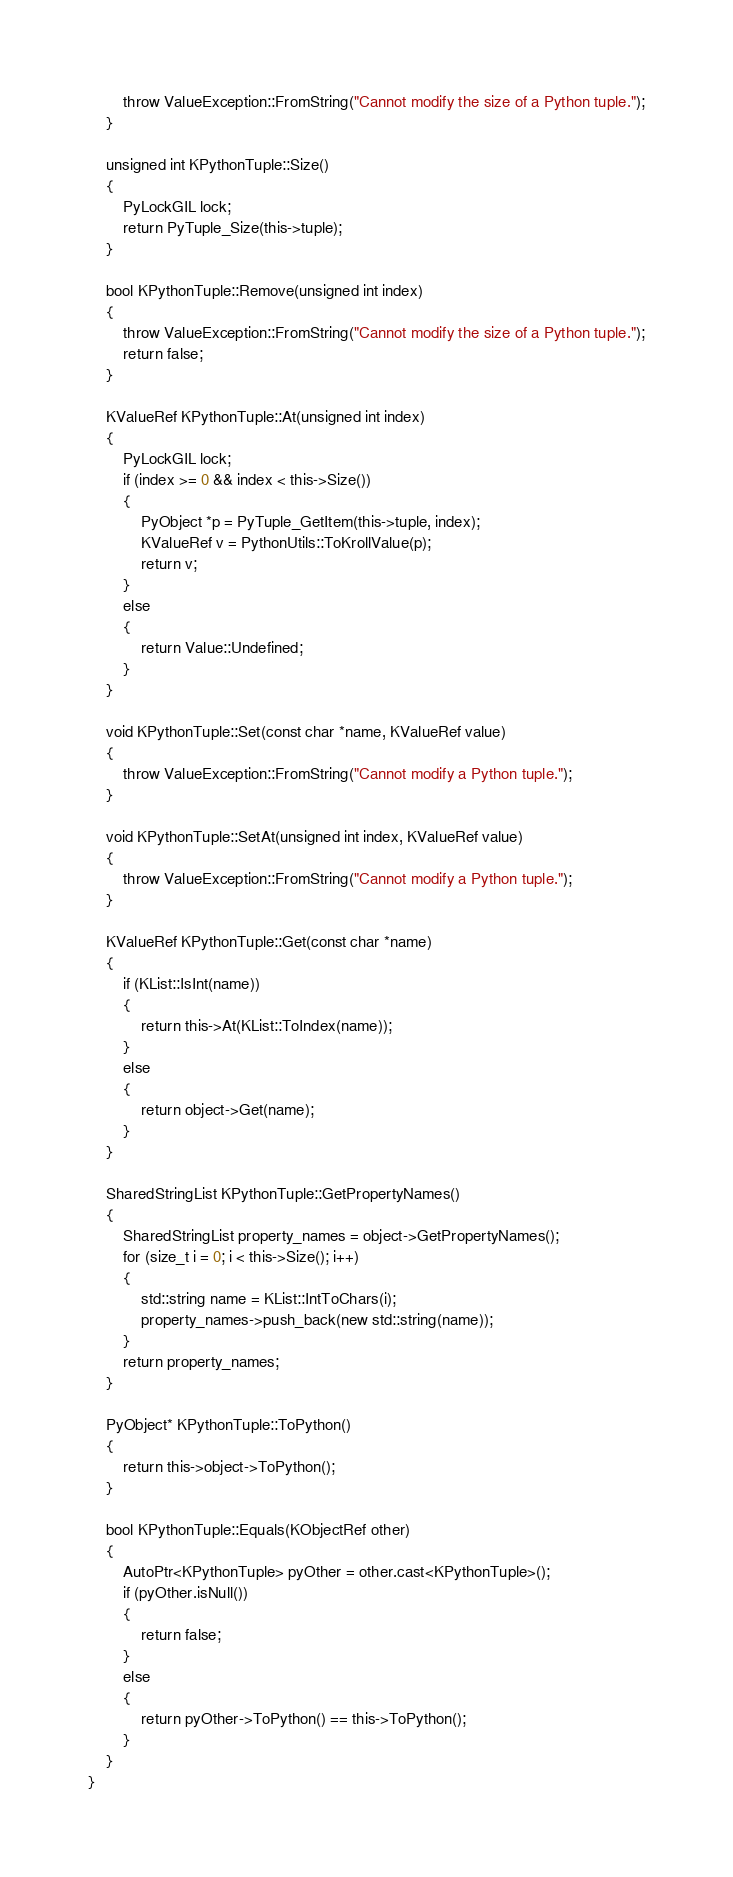<code> <loc_0><loc_0><loc_500><loc_500><_C++_>        throw ValueException::FromString("Cannot modify the size of a Python tuple.");
    }

    unsigned int KPythonTuple::Size()
    {
        PyLockGIL lock;
        return PyTuple_Size(this->tuple);
    }

    bool KPythonTuple::Remove(unsigned int index)
    {
        throw ValueException::FromString("Cannot modify the size of a Python tuple.");
        return false;
    }

    KValueRef KPythonTuple::At(unsigned int index)
    {
        PyLockGIL lock;
        if (index >= 0 && index < this->Size())
        {
            PyObject *p = PyTuple_GetItem(this->tuple, index);
            KValueRef v = PythonUtils::ToKrollValue(p);
            return v;
        }
        else
        {
            return Value::Undefined;
        }
    }

    void KPythonTuple::Set(const char *name, KValueRef value)
    {
        throw ValueException::FromString("Cannot modify a Python tuple.");
    }

    void KPythonTuple::SetAt(unsigned int index, KValueRef value)
    {
        throw ValueException::FromString("Cannot modify a Python tuple.");
    }

    KValueRef KPythonTuple::Get(const char *name)
    {
        if (KList::IsInt(name))
        {
            return this->At(KList::ToIndex(name));
        }
        else
        {
            return object->Get(name);
        }
    }

    SharedStringList KPythonTuple::GetPropertyNames()
    {
        SharedStringList property_names = object->GetPropertyNames();
        for (size_t i = 0; i < this->Size(); i++)
        {
            std::string name = KList::IntToChars(i);
            property_names->push_back(new std::string(name));
        }
        return property_names;
    }

    PyObject* KPythonTuple::ToPython()
    {
        return this->object->ToPython();
    }

    bool KPythonTuple::Equals(KObjectRef other)
    {
        AutoPtr<KPythonTuple> pyOther = other.cast<KPythonTuple>();
        if (pyOther.isNull())
        {
            return false;
        }
        else
        {
            return pyOther->ToPython() == this->ToPython();
        }
    }
}
</code> 